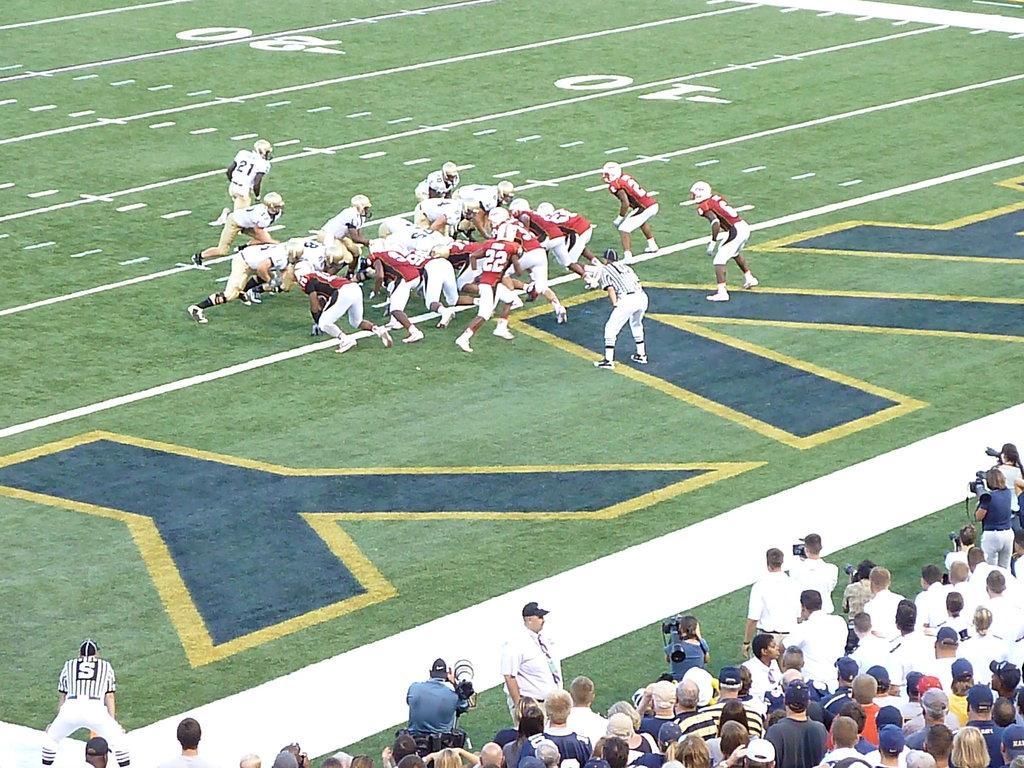How would you summarize this image in a sentence or two? In the middle a group of people playing a rugby game who are wearing a white and red color jersey. Both side of the image is covered with grass. At the bottom there are group of people standing on the ground and few are holding a camera in their hand and taking pictures. This image is taken on the pitch during day time. 